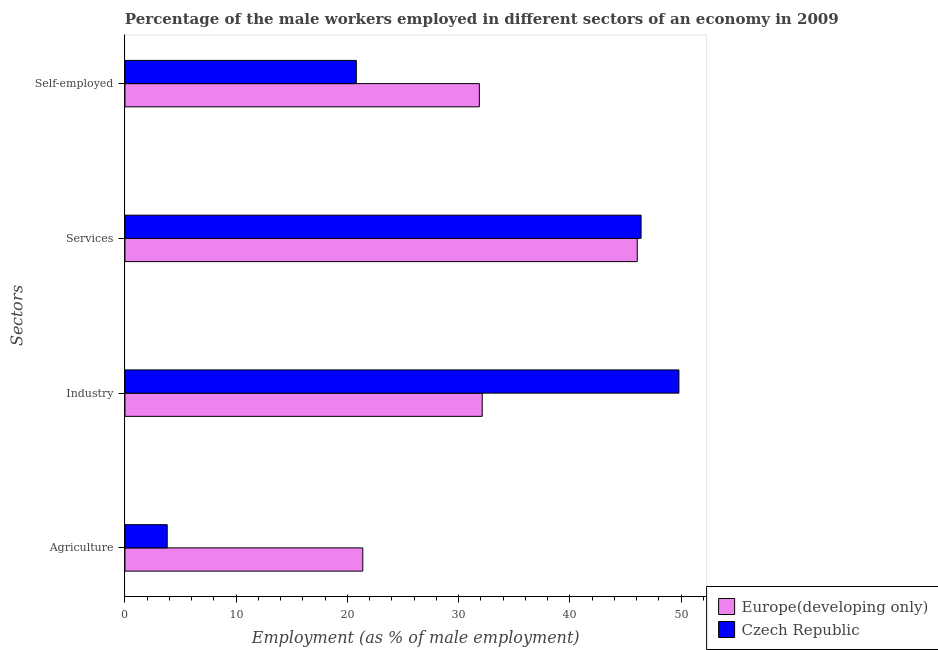How many groups of bars are there?
Make the answer very short. 4. How many bars are there on the 3rd tick from the bottom?
Your answer should be compact. 2. What is the label of the 1st group of bars from the top?
Ensure brevity in your answer.  Self-employed. What is the percentage of male workers in agriculture in Czech Republic?
Provide a short and direct response. 3.8. Across all countries, what is the maximum percentage of male workers in agriculture?
Your answer should be very brief. 21.38. Across all countries, what is the minimum percentage of male workers in agriculture?
Give a very brief answer. 3.8. In which country was the percentage of self employed male workers maximum?
Make the answer very short. Europe(developing only). In which country was the percentage of self employed male workers minimum?
Offer a very short reply. Czech Republic. What is the total percentage of male workers in agriculture in the graph?
Make the answer very short. 25.18. What is the difference between the percentage of male workers in agriculture in Czech Republic and that in Europe(developing only)?
Your answer should be very brief. -17.58. What is the difference between the percentage of male workers in services in Europe(developing only) and the percentage of self employed male workers in Czech Republic?
Give a very brief answer. 25.26. What is the average percentage of male workers in agriculture per country?
Offer a very short reply. 12.59. What is the difference between the percentage of male workers in industry and percentage of male workers in agriculture in Europe(developing only)?
Ensure brevity in your answer.  10.74. In how many countries, is the percentage of self employed male workers greater than 36 %?
Keep it short and to the point. 0. What is the ratio of the percentage of self employed male workers in Czech Republic to that in Europe(developing only)?
Your answer should be very brief. 0.65. Is the percentage of self employed male workers in Europe(developing only) less than that in Czech Republic?
Provide a succinct answer. No. Is the difference between the percentage of male workers in services in Czech Republic and Europe(developing only) greater than the difference between the percentage of self employed male workers in Czech Republic and Europe(developing only)?
Keep it short and to the point. Yes. What is the difference between the highest and the second highest percentage of male workers in services?
Offer a very short reply. 0.34. What is the difference between the highest and the lowest percentage of male workers in agriculture?
Offer a very short reply. 17.58. Is the sum of the percentage of self employed male workers in Czech Republic and Europe(developing only) greater than the maximum percentage of male workers in agriculture across all countries?
Your response must be concise. Yes. Is it the case that in every country, the sum of the percentage of self employed male workers and percentage of male workers in agriculture is greater than the sum of percentage of male workers in services and percentage of male workers in industry?
Offer a terse response. No. What does the 2nd bar from the top in Industry represents?
Provide a short and direct response. Europe(developing only). What does the 1st bar from the bottom in Services represents?
Offer a very short reply. Europe(developing only). Are all the bars in the graph horizontal?
Make the answer very short. Yes. How many countries are there in the graph?
Offer a terse response. 2. Are the values on the major ticks of X-axis written in scientific E-notation?
Ensure brevity in your answer.  No. Does the graph contain grids?
Offer a very short reply. No. How many legend labels are there?
Keep it short and to the point. 2. What is the title of the graph?
Provide a succinct answer. Percentage of the male workers employed in different sectors of an economy in 2009. What is the label or title of the X-axis?
Your response must be concise. Employment (as % of male employment). What is the label or title of the Y-axis?
Offer a very short reply. Sectors. What is the Employment (as % of male employment) of Europe(developing only) in Agriculture?
Keep it short and to the point. 21.38. What is the Employment (as % of male employment) in Czech Republic in Agriculture?
Keep it short and to the point. 3.8. What is the Employment (as % of male employment) of Europe(developing only) in Industry?
Your answer should be very brief. 32.12. What is the Employment (as % of male employment) in Czech Republic in Industry?
Give a very brief answer. 49.8. What is the Employment (as % of male employment) in Europe(developing only) in Services?
Make the answer very short. 46.06. What is the Employment (as % of male employment) of Czech Republic in Services?
Give a very brief answer. 46.4. What is the Employment (as % of male employment) of Europe(developing only) in Self-employed?
Keep it short and to the point. 31.86. What is the Employment (as % of male employment) of Czech Republic in Self-employed?
Provide a short and direct response. 20.8. Across all Sectors, what is the maximum Employment (as % of male employment) in Europe(developing only)?
Offer a very short reply. 46.06. Across all Sectors, what is the maximum Employment (as % of male employment) in Czech Republic?
Give a very brief answer. 49.8. Across all Sectors, what is the minimum Employment (as % of male employment) in Europe(developing only)?
Make the answer very short. 21.38. Across all Sectors, what is the minimum Employment (as % of male employment) of Czech Republic?
Give a very brief answer. 3.8. What is the total Employment (as % of male employment) of Europe(developing only) in the graph?
Your response must be concise. 131.42. What is the total Employment (as % of male employment) of Czech Republic in the graph?
Offer a very short reply. 120.8. What is the difference between the Employment (as % of male employment) of Europe(developing only) in Agriculture and that in Industry?
Offer a terse response. -10.74. What is the difference between the Employment (as % of male employment) in Czech Republic in Agriculture and that in Industry?
Ensure brevity in your answer.  -46. What is the difference between the Employment (as % of male employment) of Europe(developing only) in Agriculture and that in Services?
Make the answer very short. -24.67. What is the difference between the Employment (as % of male employment) of Czech Republic in Agriculture and that in Services?
Your response must be concise. -42.6. What is the difference between the Employment (as % of male employment) in Europe(developing only) in Agriculture and that in Self-employed?
Your response must be concise. -10.48. What is the difference between the Employment (as % of male employment) in Europe(developing only) in Industry and that in Services?
Offer a terse response. -13.94. What is the difference between the Employment (as % of male employment) of Europe(developing only) in Industry and that in Self-employed?
Your response must be concise. 0.26. What is the difference between the Employment (as % of male employment) in Czech Republic in Industry and that in Self-employed?
Ensure brevity in your answer.  29. What is the difference between the Employment (as % of male employment) of Europe(developing only) in Services and that in Self-employed?
Keep it short and to the point. 14.2. What is the difference between the Employment (as % of male employment) in Czech Republic in Services and that in Self-employed?
Offer a very short reply. 25.6. What is the difference between the Employment (as % of male employment) of Europe(developing only) in Agriculture and the Employment (as % of male employment) of Czech Republic in Industry?
Your response must be concise. -28.42. What is the difference between the Employment (as % of male employment) in Europe(developing only) in Agriculture and the Employment (as % of male employment) in Czech Republic in Services?
Provide a succinct answer. -25.02. What is the difference between the Employment (as % of male employment) of Europe(developing only) in Agriculture and the Employment (as % of male employment) of Czech Republic in Self-employed?
Your answer should be compact. 0.58. What is the difference between the Employment (as % of male employment) in Europe(developing only) in Industry and the Employment (as % of male employment) in Czech Republic in Services?
Offer a very short reply. -14.28. What is the difference between the Employment (as % of male employment) of Europe(developing only) in Industry and the Employment (as % of male employment) of Czech Republic in Self-employed?
Keep it short and to the point. 11.32. What is the difference between the Employment (as % of male employment) of Europe(developing only) in Services and the Employment (as % of male employment) of Czech Republic in Self-employed?
Your response must be concise. 25.26. What is the average Employment (as % of male employment) of Europe(developing only) per Sectors?
Your answer should be compact. 32.85. What is the average Employment (as % of male employment) of Czech Republic per Sectors?
Provide a succinct answer. 30.2. What is the difference between the Employment (as % of male employment) of Europe(developing only) and Employment (as % of male employment) of Czech Republic in Agriculture?
Ensure brevity in your answer.  17.58. What is the difference between the Employment (as % of male employment) in Europe(developing only) and Employment (as % of male employment) in Czech Republic in Industry?
Ensure brevity in your answer.  -17.68. What is the difference between the Employment (as % of male employment) of Europe(developing only) and Employment (as % of male employment) of Czech Republic in Services?
Your answer should be compact. -0.34. What is the difference between the Employment (as % of male employment) in Europe(developing only) and Employment (as % of male employment) in Czech Republic in Self-employed?
Provide a succinct answer. 11.06. What is the ratio of the Employment (as % of male employment) of Europe(developing only) in Agriculture to that in Industry?
Provide a short and direct response. 0.67. What is the ratio of the Employment (as % of male employment) in Czech Republic in Agriculture to that in Industry?
Your answer should be very brief. 0.08. What is the ratio of the Employment (as % of male employment) in Europe(developing only) in Agriculture to that in Services?
Make the answer very short. 0.46. What is the ratio of the Employment (as % of male employment) in Czech Republic in Agriculture to that in Services?
Provide a succinct answer. 0.08. What is the ratio of the Employment (as % of male employment) of Europe(developing only) in Agriculture to that in Self-employed?
Give a very brief answer. 0.67. What is the ratio of the Employment (as % of male employment) of Czech Republic in Agriculture to that in Self-employed?
Provide a short and direct response. 0.18. What is the ratio of the Employment (as % of male employment) of Europe(developing only) in Industry to that in Services?
Your response must be concise. 0.7. What is the ratio of the Employment (as % of male employment) in Czech Republic in Industry to that in Services?
Offer a terse response. 1.07. What is the ratio of the Employment (as % of male employment) in Czech Republic in Industry to that in Self-employed?
Offer a terse response. 2.39. What is the ratio of the Employment (as % of male employment) of Europe(developing only) in Services to that in Self-employed?
Offer a terse response. 1.45. What is the ratio of the Employment (as % of male employment) in Czech Republic in Services to that in Self-employed?
Offer a terse response. 2.23. What is the difference between the highest and the second highest Employment (as % of male employment) of Europe(developing only)?
Offer a very short reply. 13.94. What is the difference between the highest and the lowest Employment (as % of male employment) of Europe(developing only)?
Your answer should be very brief. 24.67. 